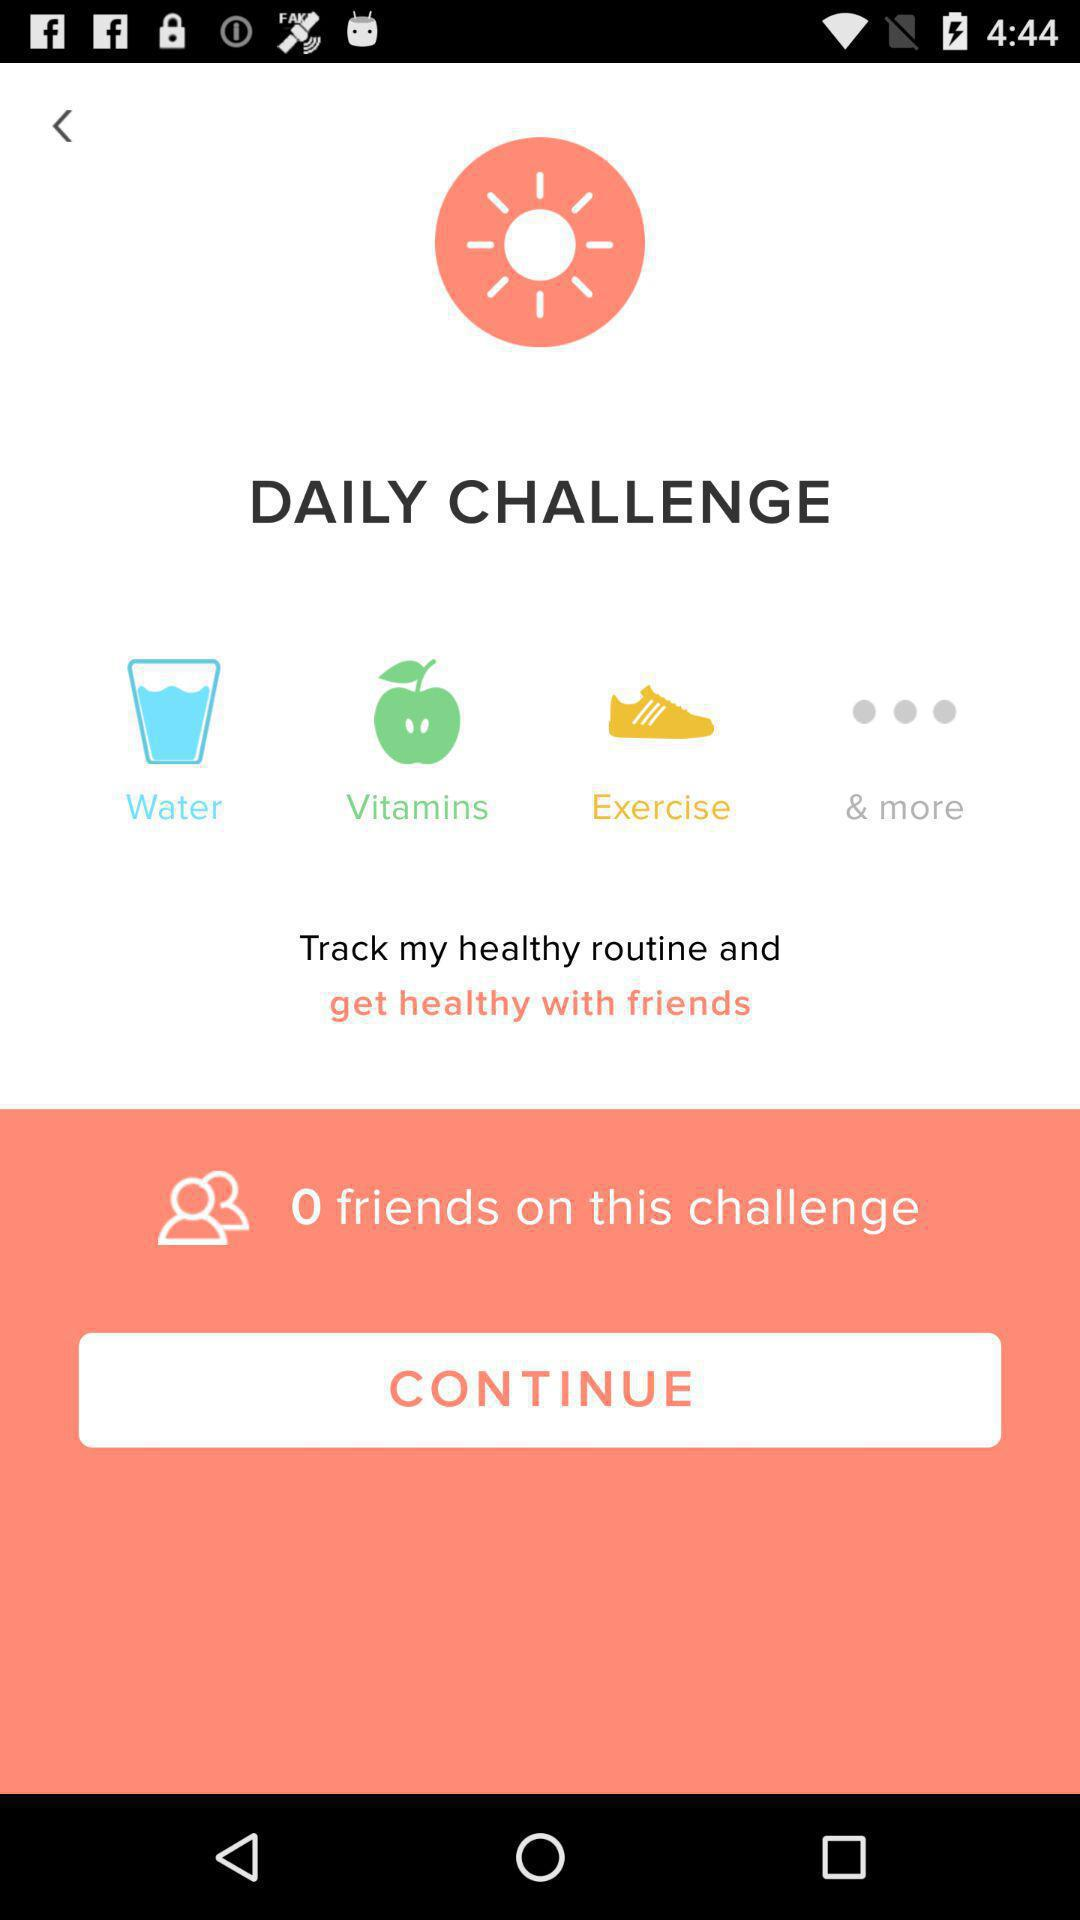What is the name of the application? The name of the application is "DAILY CHALLENGE". 